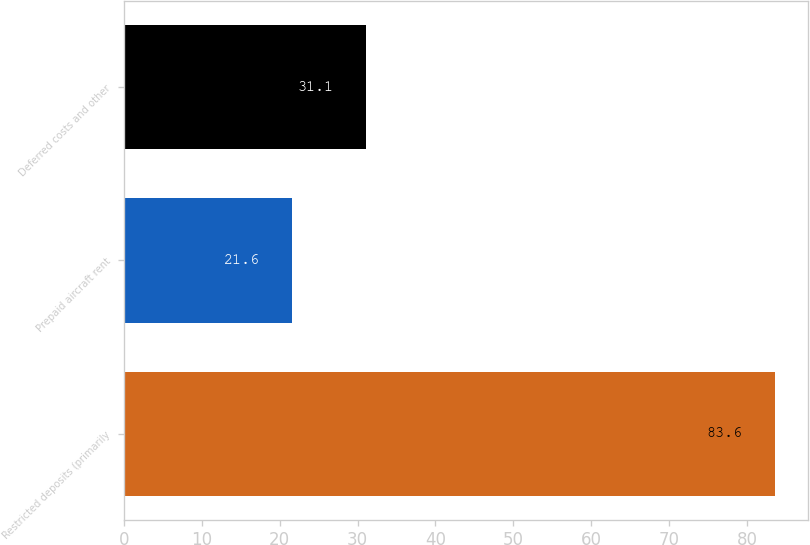Convert chart. <chart><loc_0><loc_0><loc_500><loc_500><bar_chart><fcel>Restricted deposits (primarily<fcel>Prepaid aircraft rent<fcel>Deferred costs and other<nl><fcel>83.6<fcel>21.6<fcel>31.1<nl></chart> 